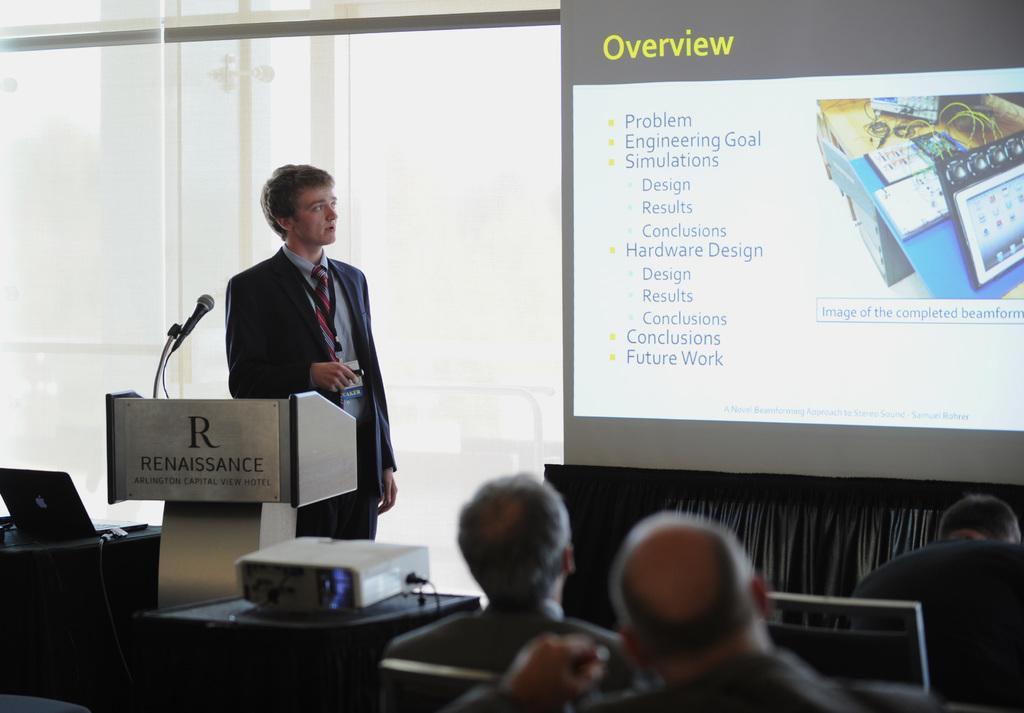Describe this image in one or two sentences. In the background we can see the glass, screen and a cloth. On the left side of the picture we can see a man is holding an object. We can see there is something written on a podium. In this picture we can see a microphone, stand. On the tables we can see a laptop, projector device. At the bottom portion of the picture we can see the people sitting on the chairs. 